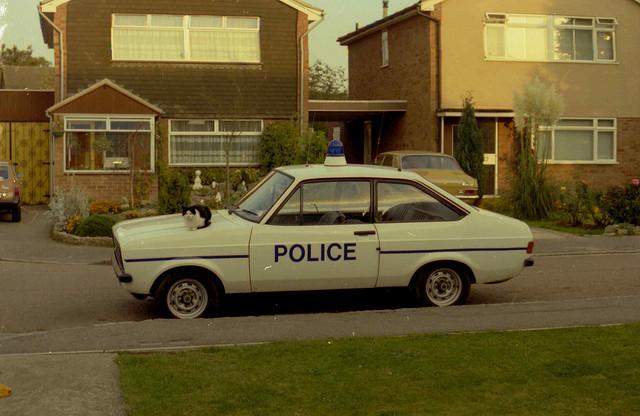What make of car is this?
Quick response, please. Ford. Is the setting a big city or small town?
Short answer required. Small town. Is the cop pulling someone over?
Quick response, please. No. What does it say on the car?
Quick response, please. Police. What is this vehicle called?
Keep it brief. Police car. What kind of vehicle is this?
Short answer required. Police. What does the bottom of the picture say?
Give a very brief answer. Police. What kind of event is pictured?
Write a very short answer. Police. What color is the car I?
Short answer required. White. What country is this?
Be succinct. America. What does the "P" stand for?
Give a very brief answer. Police. What is on top of the car?
Answer briefly. Cat. What color is the car?
Write a very short answer. White. What is mainly featured?
Keep it brief. Police car. How many cats are on the car?
Concise answer only. 1. Is the truck lifted?
Quick response, please. No. What is the cars nickname?
Concise answer only. Police. What type of vehicle is this?
Keep it brief. Police. What kind of car is this?
Answer briefly. Police. How many doors does the car have?
Answer briefly. 2. What color is the cat?
Keep it brief. Black and white. What season is this picture taken?
Be succinct. Summer. Is this a large white lunch truck?
Write a very short answer. No. Is the sidewalk crowded?
Be succinct. No. Was this picture taken in 2015?
Quick response, please. No. Is the vehicle refilling?
Write a very short answer. No. 